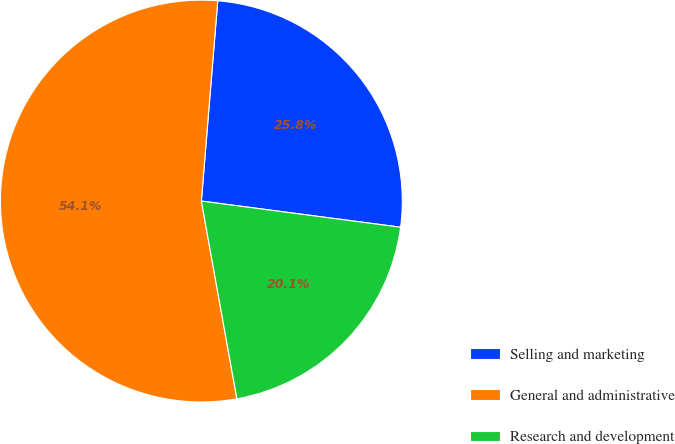Convert chart to OTSL. <chart><loc_0><loc_0><loc_500><loc_500><pie_chart><fcel>Selling and marketing<fcel>General and administrative<fcel>Research and development<nl><fcel>25.78%<fcel>54.13%<fcel>20.09%<nl></chart> 